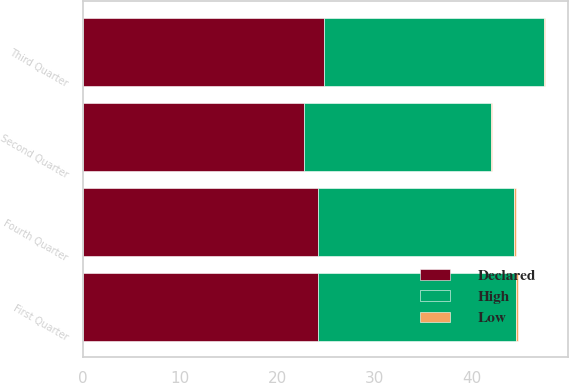Convert chart to OTSL. <chart><loc_0><loc_0><loc_500><loc_500><stacked_bar_chart><ecel><fcel>First Quarter<fcel>Second Quarter<fcel>Third Quarter<fcel>Fourth Quarter<nl><fcel>Declared<fcel>24.22<fcel>22.79<fcel>24.85<fcel>24.19<nl><fcel>High<fcel>20.41<fcel>19.18<fcel>22.57<fcel>20.23<nl><fcel>Low<fcel>0.18<fcel>0.16<fcel>0.16<fcel>0.16<nl></chart> 